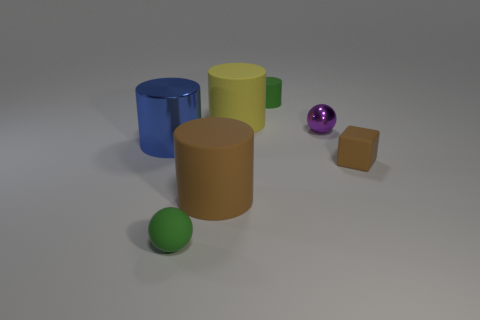Subtract all small green matte cylinders. How many cylinders are left? 3 Subtract all blue cylinders. How many cylinders are left? 3 Subtract all cubes. How many objects are left? 6 Add 1 matte things. How many objects exist? 8 Add 6 purple metallic balls. How many purple metallic balls are left? 7 Add 5 small purple metallic spheres. How many small purple metallic spheres exist? 6 Subtract 1 purple spheres. How many objects are left? 6 Subtract all brown balls. Subtract all brown cylinders. How many balls are left? 2 Subtract all purple cylinders. How many purple cubes are left? 0 Subtract all tiny blocks. Subtract all brown rubber blocks. How many objects are left? 5 